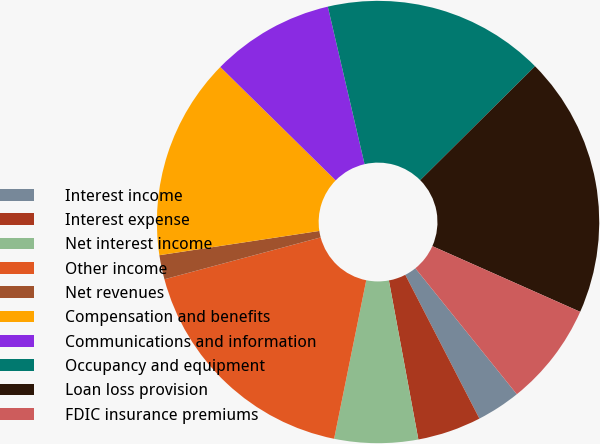Convert chart to OTSL. <chart><loc_0><loc_0><loc_500><loc_500><pie_chart><fcel>Interest income<fcel>Interest expense<fcel>Net interest income<fcel>Other income<fcel>Net revenues<fcel>Compensation and benefits<fcel>Communications and information<fcel>Occupancy and equipment<fcel>Loan loss provision<fcel>FDIC insurance premiums<nl><fcel>3.22%<fcel>4.66%<fcel>6.1%<fcel>17.65%<fcel>1.77%<fcel>14.76%<fcel>8.99%<fcel>16.21%<fcel>19.09%<fcel>7.55%<nl></chart> 